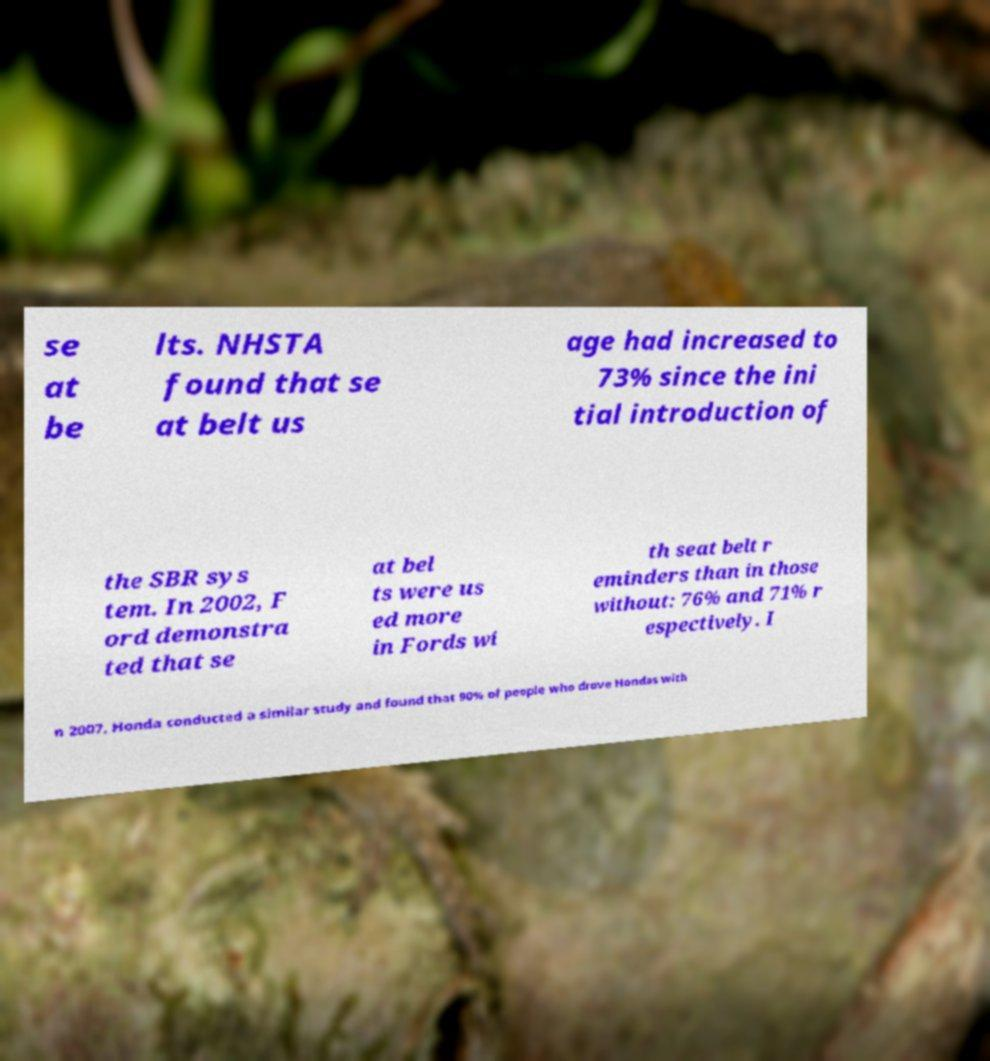Could you assist in decoding the text presented in this image and type it out clearly? se at be lts. NHSTA found that se at belt us age had increased to 73% since the ini tial introduction of the SBR sys tem. In 2002, F ord demonstra ted that se at bel ts were us ed more in Fords wi th seat belt r eminders than in those without: 76% and 71% r espectively. I n 2007, Honda conducted a similar study and found that 90% of people who drove Hondas with 